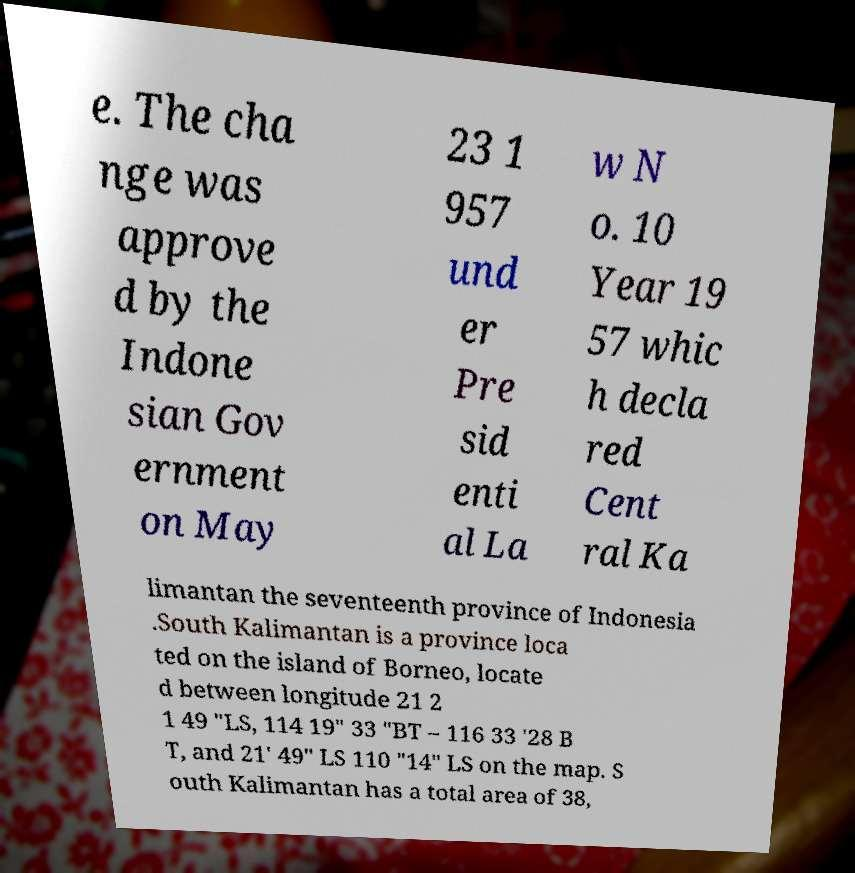I need the written content from this picture converted into text. Can you do that? e. The cha nge was approve d by the Indone sian Gov ernment on May 23 1 957 und er Pre sid enti al La w N o. 10 Year 19 57 whic h decla red Cent ral Ka limantan the seventeenth province of Indonesia .South Kalimantan is a province loca ted on the island of Borneo, locate d between longitude 21 2 1 49 "LS, 114 19" 33 "BT – 116 33 '28 B T, and 21' 49" LS 110 "14" LS on the map. S outh Kalimantan has a total area of 38, 